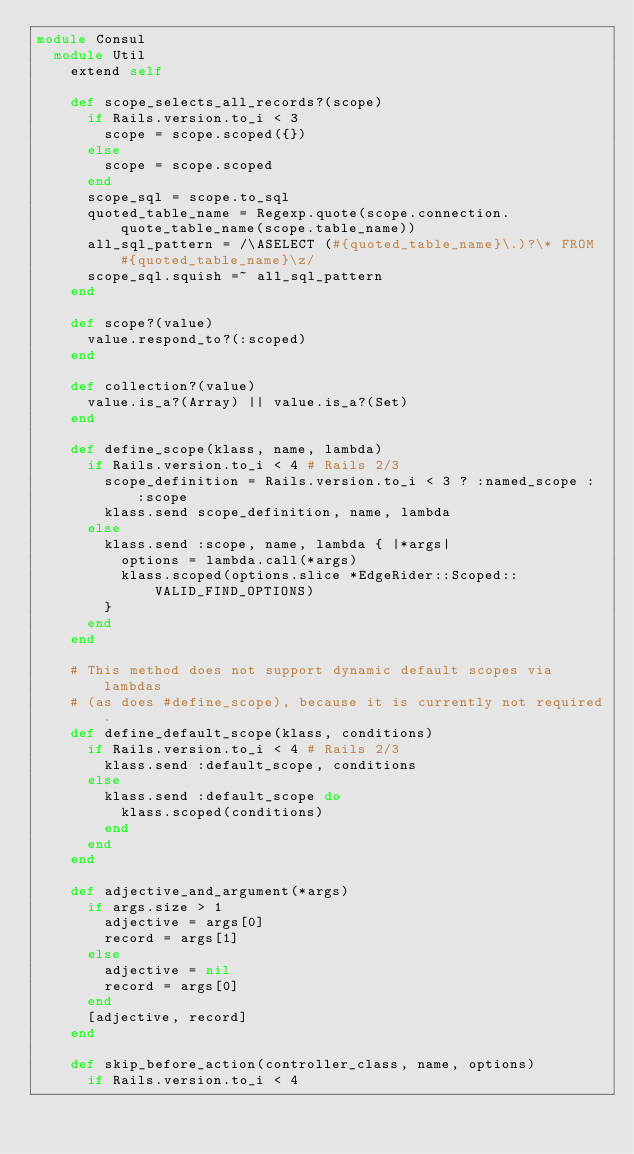Convert code to text. <code><loc_0><loc_0><loc_500><loc_500><_Ruby_>module Consul
  module Util
    extend self

    def scope_selects_all_records?(scope)
      if Rails.version.to_i < 3
        scope = scope.scoped({})
      else
        scope = scope.scoped
      end
      scope_sql = scope.to_sql
      quoted_table_name = Regexp.quote(scope.connection.quote_table_name(scope.table_name))
      all_sql_pattern = /\ASELECT (#{quoted_table_name}\.)?\* FROM #{quoted_table_name}\z/
      scope_sql.squish =~ all_sql_pattern
    end

    def scope?(value)
      value.respond_to?(:scoped)
    end

    def collection?(value)
      value.is_a?(Array) || value.is_a?(Set)
    end

    def define_scope(klass, name, lambda)
      if Rails.version.to_i < 4 # Rails 2/3
        scope_definition = Rails.version.to_i < 3 ? :named_scope : :scope
        klass.send scope_definition, name, lambda
      else
        klass.send :scope, name, lambda { |*args|
          options = lambda.call(*args)
          klass.scoped(options.slice *EdgeRider::Scoped::VALID_FIND_OPTIONS)
        }
      end      
    end
    
    # This method does not support dynamic default scopes via lambdas
    # (as does #define_scope), because it is currently not required.
    def define_default_scope(klass, conditions)
      if Rails.version.to_i < 4 # Rails 2/3
        klass.send :default_scope, conditions
      else
        klass.send :default_scope do
          klass.scoped(conditions)
        end
      end
    end

    def adjective_and_argument(*args)
      if args.size > 1
        adjective = args[0]
        record = args[1]
      else
        adjective = nil
        record = args[0]
      end
      [adjective, record]
    end

    def skip_before_action(controller_class, name, options)
      if Rails.version.to_i < 4</code> 